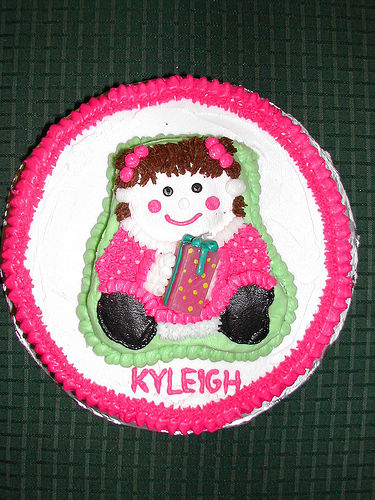<image>
Is there a girl on the cake? Yes. Looking at the image, I can see the girl is positioned on top of the cake, with the cake providing support. 